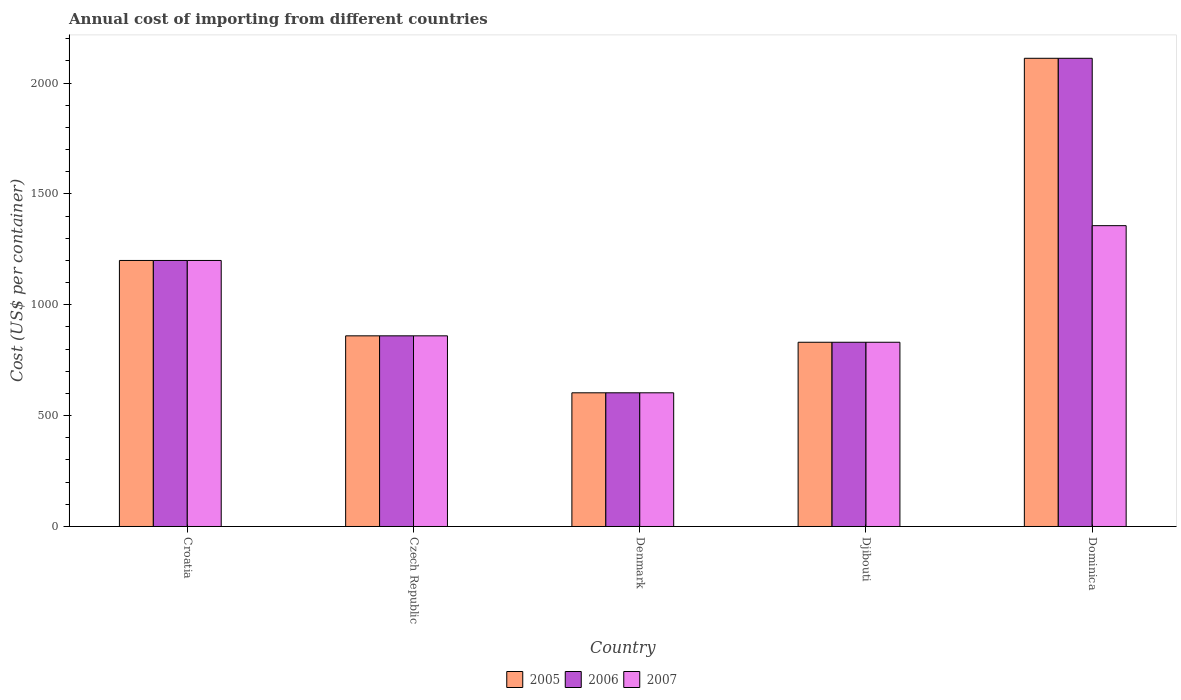How many groups of bars are there?
Provide a succinct answer. 5. Are the number of bars per tick equal to the number of legend labels?
Offer a terse response. Yes. Are the number of bars on each tick of the X-axis equal?
Your response must be concise. Yes. How many bars are there on the 3rd tick from the left?
Offer a terse response. 3. What is the label of the 3rd group of bars from the left?
Provide a short and direct response. Denmark. In how many cases, is the number of bars for a given country not equal to the number of legend labels?
Provide a succinct answer. 0. What is the total annual cost of importing in 2006 in Czech Republic?
Your response must be concise. 860. Across all countries, what is the maximum total annual cost of importing in 2007?
Provide a short and direct response. 1357. Across all countries, what is the minimum total annual cost of importing in 2007?
Offer a terse response. 603. In which country was the total annual cost of importing in 2005 maximum?
Make the answer very short. Dominica. What is the total total annual cost of importing in 2005 in the graph?
Provide a short and direct response. 5606. What is the difference between the total annual cost of importing in 2006 in Czech Republic and that in Djibouti?
Provide a succinct answer. 29. What is the difference between the total annual cost of importing in 2006 in Czech Republic and the total annual cost of importing in 2005 in Dominica?
Your response must be concise. -1252. What is the average total annual cost of importing in 2006 per country?
Keep it short and to the point. 1121.2. What is the difference between the total annual cost of importing of/in 2006 and total annual cost of importing of/in 2005 in Croatia?
Make the answer very short. 0. What is the ratio of the total annual cost of importing in 2005 in Croatia to that in Dominica?
Offer a very short reply. 0.57. Is the total annual cost of importing in 2005 in Croatia less than that in Denmark?
Provide a succinct answer. No. What is the difference between the highest and the second highest total annual cost of importing in 2006?
Give a very brief answer. 1252. What is the difference between the highest and the lowest total annual cost of importing in 2005?
Make the answer very short. 1509. Is the sum of the total annual cost of importing in 2007 in Czech Republic and Dominica greater than the maximum total annual cost of importing in 2006 across all countries?
Your answer should be compact. Yes. Are all the bars in the graph horizontal?
Your response must be concise. No. How many countries are there in the graph?
Your answer should be very brief. 5. What is the difference between two consecutive major ticks on the Y-axis?
Your answer should be very brief. 500. Are the values on the major ticks of Y-axis written in scientific E-notation?
Make the answer very short. No. Does the graph contain grids?
Make the answer very short. No. Where does the legend appear in the graph?
Offer a terse response. Bottom center. How many legend labels are there?
Provide a short and direct response. 3. How are the legend labels stacked?
Your answer should be compact. Horizontal. What is the title of the graph?
Provide a succinct answer. Annual cost of importing from different countries. Does "2006" appear as one of the legend labels in the graph?
Your answer should be very brief. Yes. What is the label or title of the X-axis?
Provide a succinct answer. Country. What is the label or title of the Y-axis?
Offer a terse response. Cost (US$ per container). What is the Cost (US$ per container) in 2005 in Croatia?
Offer a very short reply. 1200. What is the Cost (US$ per container) in 2006 in Croatia?
Make the answer very short. 1200. What is the Cost (US$ per container) of 2007 in Croatia?
Your answer should be very brief. 1200. What is the Cost (US$ per container) in 2005 in Czech Republic?
Give a very brief answer. 860. What is the Cost (US$ per container) in 2006 in Czech Republic?
Offer a very short reply. 860. What is the Cost (US$ per container) of 2007 in Czech Republic?
Provide a short and direct response. 860. What is the Cost (US$ per container) of 2005 in Denmark?
Make the answer very short. 603. What is the Cost (US$ per container) of 2006 in Denmark?
Give a very brief answer. 603. What is the Cost (US$ per container) in 2007 in Denmark?
Your answer should be compact. 603. What is the Cost (US$ per container) in 2005 in Djibouti?
Make the answer very short. 831. What is the Cost (US$ per container) of 2006 in Djibouti?
Provide a succinct answer. 831. What is the Cost (US$ per container) in 2007 in Djibouti?
Your answer should be very brief. 831. What is the Cost (US$ per container) of 2005 in Dominica?
Your answer should be compact. 2112. What is the Cost (US$ per container) in 2006 in Dominica?
Provide a succinct answer. 2112. What is the Cost (US$ per container) in 2007 in Dominica?
Your answer should be compact. 1357. Across all countries, what is the maximum Cost (US$ per container) in 2005?
Provide a succinct answer. 2112. Across all countries, what is the maximum Cost (US$ per container) of 2006?
Give a very brief answer. 2112. Across all countries, what is the maximum Cost (US$ per container) in 2007?
Provide a short and direct response. 1357. Across all countries, what is the minimum Cost (US$ per container) of 2005?
Offer a very short reply. 603. Across all countries, what is the minimum Cost (US$ per container) in 2006?
Offer a very short reply. 603. Across all countries, what is the minimum Cost (US$ per container) in 2007?
Your answer should be compact. 603. What is the total Cost (US$ per container) of 2005 in the graph?
Ensure brevity in your answer.  5606. What is the total Cost (US$ per container) in 2006 in the graph?
Offer a terse response. 5606. What is the total Cost (US$ per container) in 2007 in the graph?
Ensure brevity in your answer.  4851. What is the difference between the Cost (US$ per container) of 2005 in Croatia and that in Czech Republic?
Make the answer very short. 340. What is the difference between the Cost (US$ per container) of 2006 in Croatia and that in Czech Republic?
Your answer should be very brief. 340. What is the difference between the Cost (US$ per container) in 2007 in Croatia and that in Czech Republic?
Your answer should be compact. 340. What is the difference between the Cost (US$ per container) of 2005 in Croatia and that in Denmark?
Offer a very short reply. 597. What is the difference between the Cost (US$ per container) in 2006 in Croatia and that in Denmark?
Make the answer very short. 597. What is the difference between the Cost (US$ per container) in 2007 in Croatia and that in Denmark?
Your answer should be compact. 597. What is the difference between the Cost (US$ per container) of 2005 in Croatia and that in Djibouti?
Ensure brevity in your answer.  369. What is the difference between the Cost (US$ per container) of 2006 in Croatia and that in Djibouti?
Offer a terse response. 369. What is the difference between the Cost (US$ per container) in 2007 in Croatia and that in Djibouti?
Offer a terse response. 369. What is the difference between the Cost (US$ per container) of 2005 in Croatia and that in Dominica?
Offer a terse response. -912. What is the difference between the Cost (US$ per container) of 2006 in Croatia and that in Dominica?
Provide a short and direct response. -912. What is the difference between the Cost (US$ per container) of 2007 in Croatia and that in Dominica?
Give a very brief answer. -157. What is the difference between the Cost (US$ per container) of 2005 in Czech Republic and that in Denmark?
Provide a succinct answer. 257. What is the difference between the Cost (US$ per container) of 2006 in Czech Republic and that in Denmark?
Offer a very short reply. 257. What is the difference between the Cost (US$ per container) in 2007 in Czech Republic and that in Denmark?
Your response must be concise. 257. What is the difference between the Cost (US$ per container) of 2005 in Czech Republic and that in Djibouti?
Make the answer very short. 29. What is the difference between the Cost (US$ per container) of 2006 in Czech Republic and that in Djibouti?
Keep it short and to the point. 29. What is the difference between the Cost (US$ per container) of 2005 in Czech Republic and that in Dominica?
Make the answer very short. -1252. What is the difference between the Cost (US$ per container) of 2006 in Czech Republic and that in Dominica?
Your answer should be very brief. -1252. What is the difference between the Cost (US$ per container) in 2007 in Czech Republic and that in Dominica?
Provide a short and direct response. -497. What is the difference between the Cost (US$ per container) in 2005 in Denmark and that in Djibouti?
Give a very brief answer. -228. What is the difference between the Cost (US$ per container) of 2006 in Denmark and that in Djibouti?
Make the answer very short. -228. What is the difference between the Cost (US$ per container) in 2007 in Denmark and that in Djibouti?
Your answer should be compact. -228. What is the difference between the Cost (US$ per container) in 2005 in Denmark and that in Dominica?
Offer a terse response. -1509. What is the difference between the Cost (US$ per container) of 2006 in Denmark and that in Dominica?
Make the answer very short. -1509. What is the difference between the Cost (US$ per container) in 2007 in Denmark and that in Dominica?
Keep it short and to the point. -754. What is the difference between the Cost (US$ per container) in 2005 in Djibouti and that in Dominica?
Your answer should be compact. -1281. What is the difference between the Cost (US$ per container) of 2006 in Djibouti and that in Dominica?
Give a very brief answer. -1281. What is the difference between the Cost (US$ per container) in 2007 in Djibouti and that in Dominica?
Give a very brief answer. -526. What is the difference between the Cost (US$ per container) of 2005 in Croatia and the Cost (US$ per container) of 2006 in Czech Republic?
Offer a very short reply. 340. What is the difference between the Cost (US$ per container) in 2005 in Croatia and the Cost (US$ per container) in 2007 in Czech Republic?
Give a very brief answer. 340. What is the difference between the Cost (US$ per container) in 2006 in Croatia and the Cost (US$ per container) in 2007 in Czech Republic?
Provide a succinct answer. 340. What is the difference between the Cost (US$ per container) of 2005 in Croatia and the Cost (US$ per container) of 2006 in Denmark?
Offer a terse response. 597. What is the difference between the Cost (US$ per container) in 2005 in Croatia and the Cost (US$ per container) in 2007 in Denmark?
Offer a very short reply. 597. What is the difference between the Cost (US$ per container) in 2006 in Croatia and the Cost (US$ per container) in 2007 in Denmark?
Offer a very short reply. 597. What is the difference between the Cost (US$ per container) of 2005 in Croatia and the Cost (US$ per container) of 2006 in Djibouti?
Make the answer very short. 369. What is the difference between the Cost (US$ per container) in 2005 in Croatia and the Cost (US$ per container) in 2007 in Djibouti?
Your answer should be very brief. 369. What is the difference between the Cost (US$ per container) of 2006 in Croatia and the Cost (US$ per container) of 2007 in Djibouti?
Offer a terse response. 369. What is the difference between the Cost (US$ per container) in 2005 in Croatia and the Cost (US$ per container) in 2006 in Dominica?
Your answer should be very brief. -912. What is the difference between the Cost (US$ per container) in 2005 in Croatia and the Cost (US$ per container) in 2007 in Dominica?
Offer a very short reply. -157. What is the difference between the Cost (US$ per container) of 2006 in Croatia and the Cost (US$ per container) of 2007 in Dominica?
Your answer should be very brief. -157. What is the difference between the Cost (US$ per container) of 2005 in Czech Republic and the Cost (US$ per container) of 2006 in Denmark?
Give a very brief answer. 257. What is the difference between the Cost (US$ per container) in 2005 in Czech Republic and the Cost (US$ per container) in 2007 in Denmark?
Your answer should be compact. 257. What is the difference between the Cost (US$ per container) in 2006 in Czech Republic and the Cost (US$ per container) in 2007 in Denmark?
Ensure brevity in your answer.  257. What is the difference between the Cost (US$ per container) of 2005 in Czech Republic and the Cost (US$ per container) of 2006 in Djibouti?
Make the answer very short. 29. What is the difference between the Cost (US$ per container) in 2005 in Czech Republic and the Cost (US$ per container) in 2007 in Djibouti?
Your answer should be very brief. 29. What is the difference between the Cost (US$ per container) in 2006 in Czech Republic and the Cost (US$ per container) in 2007 in Djibouti?
Offer a terse response. 29. What is the difference between the Cost (US$ per container) in 2005 in Czech Republic and the Cost (US$ per container) in 2006 in Dominica?
Ensure brevity in your answer.  -1252. What is the difference between the Cost (US$ per container) in 2005 in Czech Republic and the Cost (US$ per container) in 2007 in Dominica?
Offer a terse response. -497. What is the difference between the Cost (US$ per container) in 2006 in Czech Republic and the Cost (US$ per container) in 2007 in Dominica?
Ensure brevity in your answer.  -497. What is the difference between the Cost (US$ per container) of 2005 in Denmark and the Cost (US$ per container) of 2006 in Djibouti?
Provide a succinct answer. -228. What is the difference between the Cost (US$ per container) of 2005 in Denmark and the Cost (US$ per container) of 2007 in Djibouti?
Provide a succinct answer. -228. What is the difference between the Cost (US$ per container) in 2006 in Denmark and the Cost (US$ per container) in 2007 in Djibouti?
Your answer should be compact. -228. What is the difference between the Cost (US$ per container) of 2005 in Denmark and the Cost (US$ per container) of 2006 in Dominica?
Keep it short and to the point. -1509. What is the difference between the Cost (US$ per container) of 2005 in Denmark and the Cost (US$ per container) of 2007 in Dominica?
Provide a short and direct response. -754. What is the difference between the Cost (US$ per container) of 2006 in Denmark and the Cost (US$ per container) of 2007 in Dominica?
Your response must be concise. -754. What is the difference between the Cost (US$ per container) in 2005 in Djibouti and the Cost (US$ per container) in 2006 in Dominica?
Ensure brevity in your answer.  -1281. What is the difference between the Cost (US$ per container) of 2005 in Djibouti and the Cost (US$ per container) of 2007 in Dominica?
Provide a succinct answer. -526. What is the difference between the Cost (US$ per container) in 2006 in Djibouti and the Cost (US$ per container) in 2007 in Dominica?
Ensure brevity in your answer.  -526. What is the average Cost (US$ per container) in 2005 per country?
Provide a succinct answer. 1121.2. What is the average Cost (US$ per container) in 2006 per country?
Provide a short and direct response. 1121.2. What is the average Cost (US$ per container) in 2007 per country?
Make the answer very short. 970.2. What is the difference between the Cost (US$ per container) in 2005 and Cost (US$ per container) in 2006 in Denmark?
Make the answer very short. 0. What is the difference between the Cost (US$ per container) of 2005 and Cost (US$ per container) of 2007 in Denmark?
Offer a very short reply. 0. What is the difference between the Cost (US$ per container) in 2006 and Cost (US$ per container) in 2007 in Denmark?
Your response must be concise. 0. What is the difference between the Cost (US$ per container) of 2005 and Cost (US$ per container) of 2006 in Djibouti?
Your response must be concise. 0. What is the difference between the Cost (US$ per container) of 2005 and Cost (US$ per container) of 2006 in Dominica?
Your answer should be compact. 0. What is the difference between the Cost (US$ per container) of 2005 and Cost (US$ per container) of 2007 in Dominica?
Keep it short and to the point. 755. What is the difference between the Cost (US$ per container) of 2006 and Cost (US$ per container) of 2007 in Dominica?
Your response must be concise. 755. What is the ratio of the Cost (US$ per container) in 2005 in Croatia to that in Czech Republic?
Give a very brief answer. 1.4. What is the ratio of the Cost (US$ per container) of 2006 in Croatia to that in Czech Republic?
Offer a very short reply. 1.4. What is the ratio of the Cost (US$ per container) in 2007 in Croatia to that in Czech Republic?
Provide a short and direct response. 1.4. What is the ratio of the Cost (US$ per container) in 2005 in Croatia to that in Denmark?
Make the answer very short. 1.99. What is the ratio of the Cost (US$ per container) in 2006 in Croatia to that in Denmark?
Give a very brief answer. 1.99. What is the ratio of the Cost (US$ per container) in 2007 in Croatia to that in Denmark?
Offer a very short reply. 1.99. What is the ratio of the Cost (US$ per container) in 2005 in Croatia to that in Djibouti?
Give a very brief answer. 1.44. What is the ratio of the Cost (US$ per container) in 2006 in Croatia to that in Djibouti?
Give a very brief answer. 1.44. What is the ratio of the Cost (US$ per container) of 2007 in Croatia to that in Djibouti?
Give a very brief answer. 1.44. What is the ratio of the Cost (US$ per container) of 2005 in Croatia to that in Dominica?
Ensure brevity in your answer.  0.57. What is the ratio of the Cost (US$ per container) of 2006 in Croatia to that in Dominica?
Make the answer very short. 0.57. What is the ratio of the Cost (US$ per container) in 2007 in Croatia to that in Dominica?
Offer a terse response. 0.88. What is the ratio of the Cost (US$ per container) of 2005 in Czech Republic to that in Denmark?
Your response must be concise. 1.43. What is the ratio of the Cost (US$ per container) in 2006 in Czech Republic to that in Denmark?
Give a very brief answer. 1.43. What is the ratio of the Cost (US$ per container) of 2007 in Czech Republic to that in Denmark?
Provide a succinct answer. 1.43. What is the ratio of the Cost (US$ per container) in 2005 in Czech Republic to that in Djibouti?
Your response must be concise. 1.03. What is the ratio of the Cost (US$ per container) of 2006 in Czech Republic to that in Djibouti?
Give a very brief answer. 1.03. What is the ratio of the Cost (US$ per container) of 2007 in Czech Republic to that in Djibouti?
Make the answer very short. 1.03. What is the ratio of the Cost (US$ per container) in 2005 in Czech Republic to that in Dominica?
Keep it short and to the point. 0.41. What is the ratio of the Cost (US$ per container) of 2006 in Czech Republic to that in Dominica?
Make the answer very short. 0.41. What is the ratio of the Cost (US$ per container) of 2007 in Czech Republic to that in Dominica?
Offer a very short reply. 0.63. What is the ratio of the Cost (US$ per container) of 2005 in Denmark to that in Djibouti?
Offer a very short reply. 0.73. What is the ratio of the Cost (US$ per container) in 2006 in Denmark to that in Djibouti?
Your response must be concise. 0.73. What is the ratio of the Cost (US$ per container) in 2007 in Denmark to that in Djibouti?
Give a very brief answer. 0.73. What is the ratio of the Cost (US$ per container) in 2005 in Denmark to that in Dominica?
Make the answer very short. 0.29. What is the ratio of the Cost (US$ per container) in 2006 in Denmark to that in Dominica?
Provide a succinct answer. 0.29. What is the ratio of the Cost (US$ per container) in 2007 in Denmark to that in Dominica?
Your answer should be compact. 0.44. What is the ratio of the Cost (US$ per container) of 2005 in Djibouti to that in Dominica?
Provide a short and direct response. 0.39. What is the ratio of the Cost (US$ per container) in 2006 in Djibouti to that in Dominica?
Provide a succinct answer. 0.39. What is the ratio of the Cost (US$ per container) in 2007 in Djibouti to that in Dominica?
Your response must be concise. 0.61. What is the difference between the highest and the second highest Cost (US$ per container) of 2005?
Your response must be concise. 912. What is the difference between the highest and the second highest Cost (US$ per container) in 2006?
Offer a very short reply. 912. What is the difference between the highest and the second highest Cost (US$ per container) of 2007?
Provide a short and direct response. 157. What is the difference between the highest and the lowest Cost (US$ per container) in 2005?
Make the answer very short. 1509. What is the difference between the highest and the lowest Cost (US$ per container) in 2006?
Offer a very short reply. 1509. What is the difference between the highest and the lowest Cost (US$ per container) of 2007?
Make the answer very short. 754. 